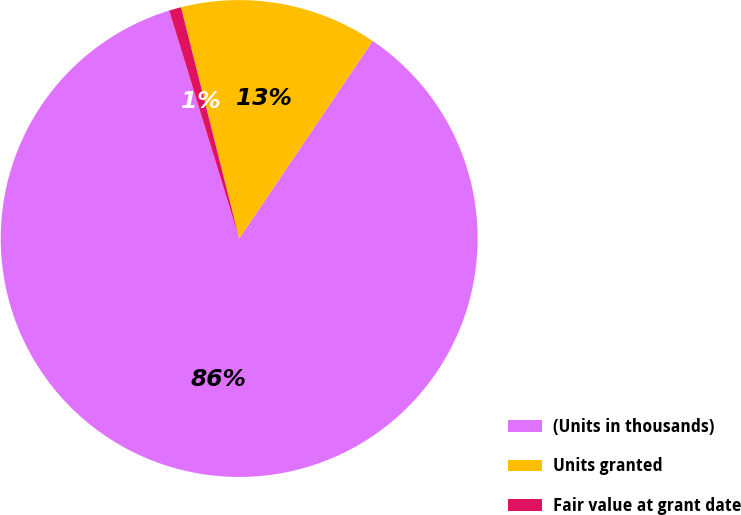<chart> <loc_0><loc_0><loc_500><loc_500><pie_chart><fcel>(Units in thousands)<fcel>Units granted<fcel>Fair value at grant date<nl><fcel>85.8%<fcel>13.38%<fcel>0.82%<nl></chart> 